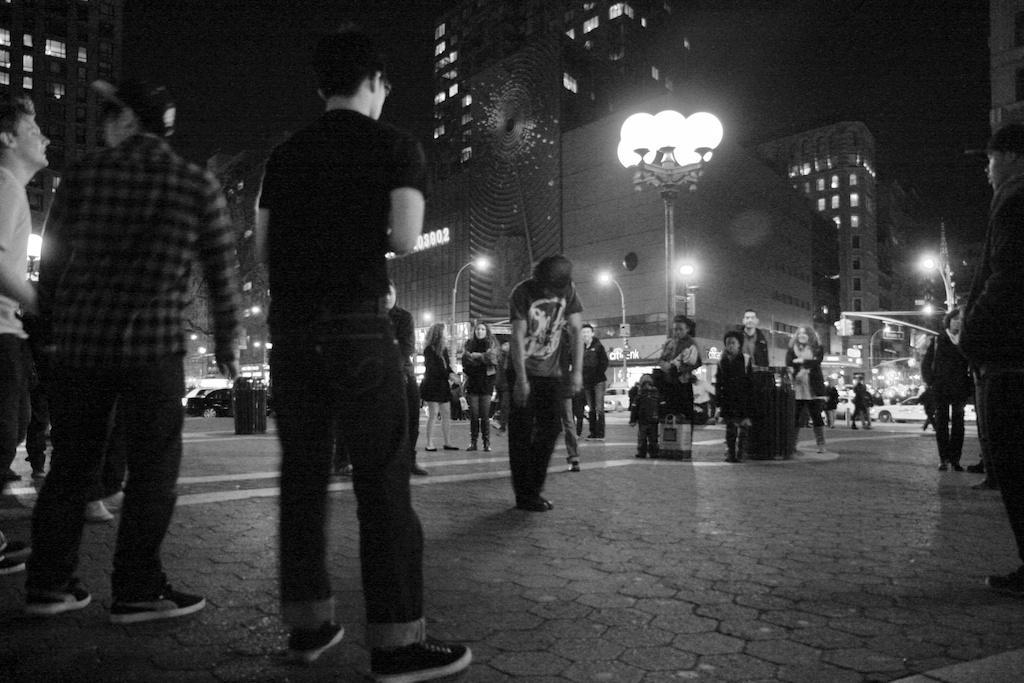How would you summarize this image in a sentence or two? This is a black and white picture. Here we can see group of people. There are poles, lights, and buildings. There is a dark background. 